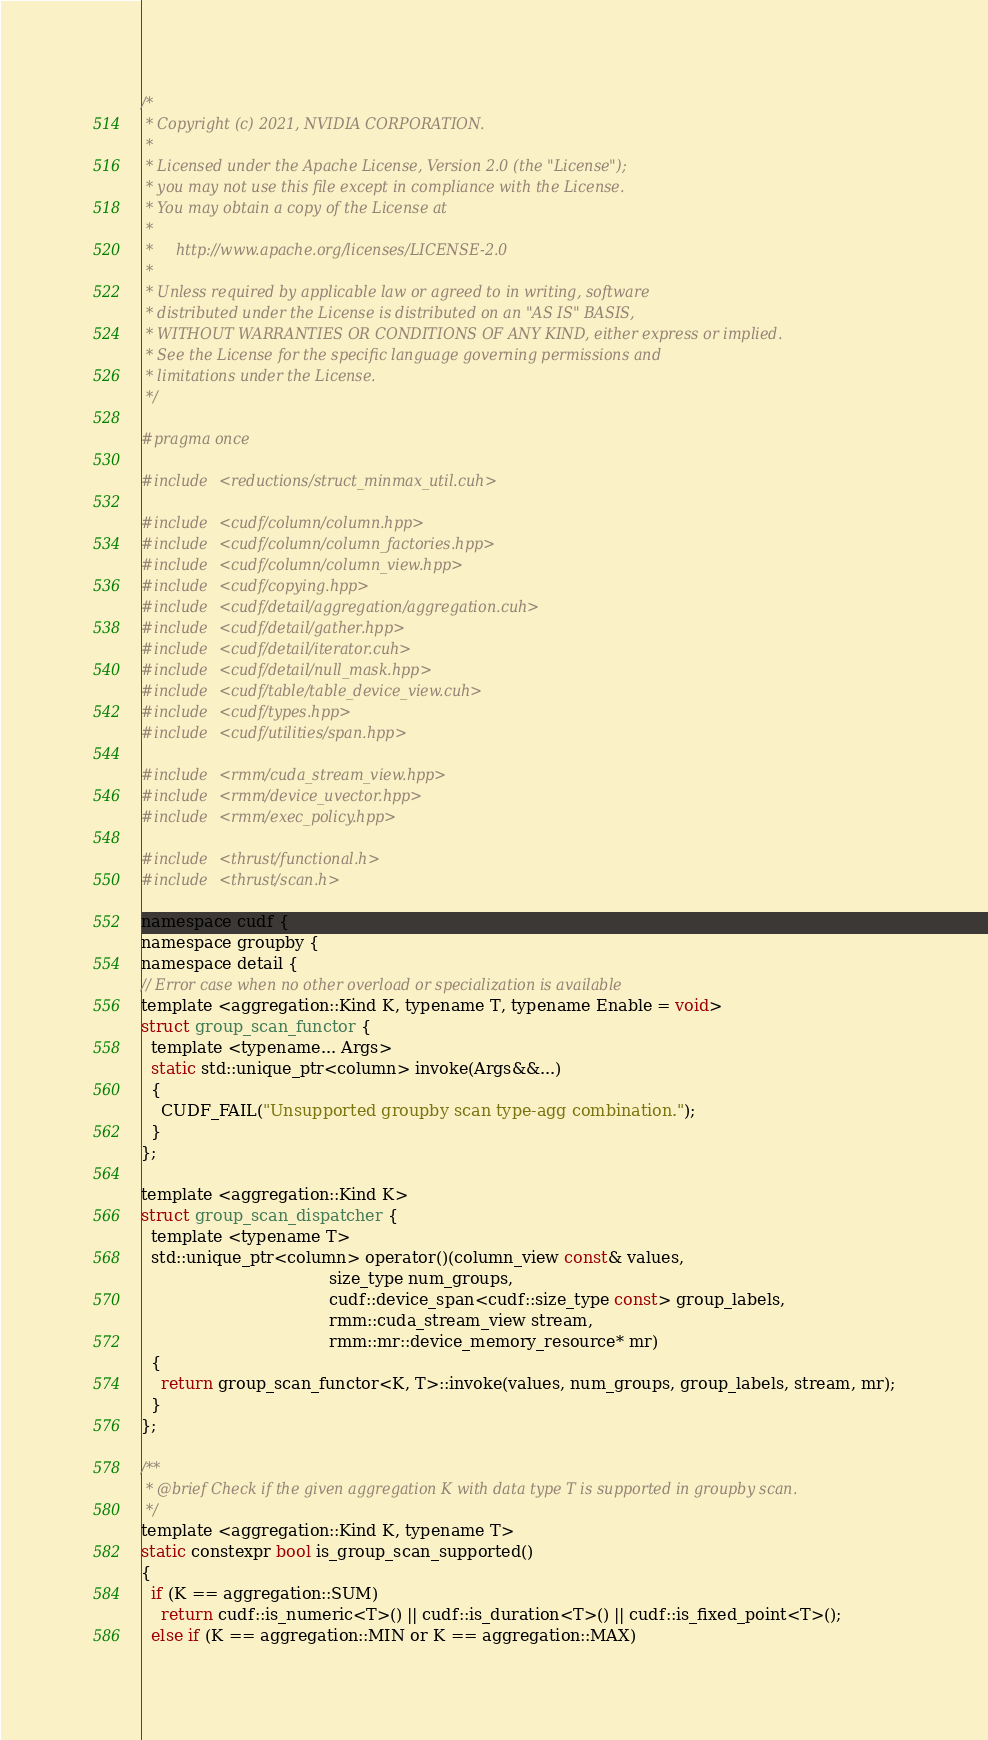Convert code to text. <code><loc_0><loc_0><loc_500><loc_500><_Cuda_>/*
 * Copyright (c) 2021, NVIDIA CORPORATION.
 *
 * Licensed under the Apache License, Version 2.0 (the "License");
 * you may not use this file except in compliance with the License.
 * You may obtain a copy of the License at
 *
 *     http://www.apache.org/licenses/LICENSE-2.0
 *
 * Unless required by applicable law or agreed to in writing, software
 * distributed under the License is distributed on an "AS IS" BASIS,
 * WITHOUT WARRANTIES OR CONDITIONS OF ANY KIND, either express or implied.
 * See the License for the specific language governing permissions and
 * limitations under the License.
 */

#pragma once

#include <reductions/struct_minmax_util.cuh>

#include <cudf/column/column.hpp>
#include <cudf/column/column_factories.hpp>
#include <cudf/column/column_view.hpp>
#include <cudf/copying.hpp>
#include <cudf/detail/aggregation/aggregation.cuh>
#include <cudf/detail/gather.hpp>
#include <cudf/detail/iterator.cuh>
#include <cudf/detail/null_mask.hpp>
#include <cudf/table/table_device_view.cuh>
#include <cudf/types.hpp>
#include <cudf/utilities/span.hpp>

#include <rmm/cuda_stream_view.hpp>
#include <rmm/device_uvector.hpp>
#include <rmm/exec_policy.hpp>

#include <thrust/functional.h>
#include <thrust/scan.h>

namespace cudf {
namespace groupby {
namespace detail {
// Error case when no other overload or specialization is available
template <aggregation::Kind K, typename T, typename Enable = void>
struct group_scan_functor {
  template <typename... Args>
  static std::unique_ptr<column> invoke(Args&&...)
  {
    CUDF_FAIL("Unsupported groupby scan type-agg combination.");
  }
};

template <aggregation::Kind K>
struct group_scan_dispatcher {
  template <typename T>
  std::unique_ptr<column> operator()(column_view const& values,
                                     size_type num_groups,
                                     cudf::device_span<cudf::size_type const> group_labels,
                                     rmm::cuda_stream_view stream,
                                     rmm::mr::device_memory_resource* mr)
  {
    return group_scan_functor<K, T>::invoke(values, num_groups, group_labels, stream, mr);
  }
};

/**
 * @brief Check if the given aggregation K with data type T is supported in groupby scan.
 */
template <aggregation::Kind K, typename T>
static constexpr bool is_group_scan_supported()
{
  if (K == aggregation::SUM)
    return cudf::is_numeric<T>() || cudf::is_duration<T>() || cudf::is_fixed_point<T>();
  else if (K == aggregation::MIN or K == aggregation::MAX)</code> 